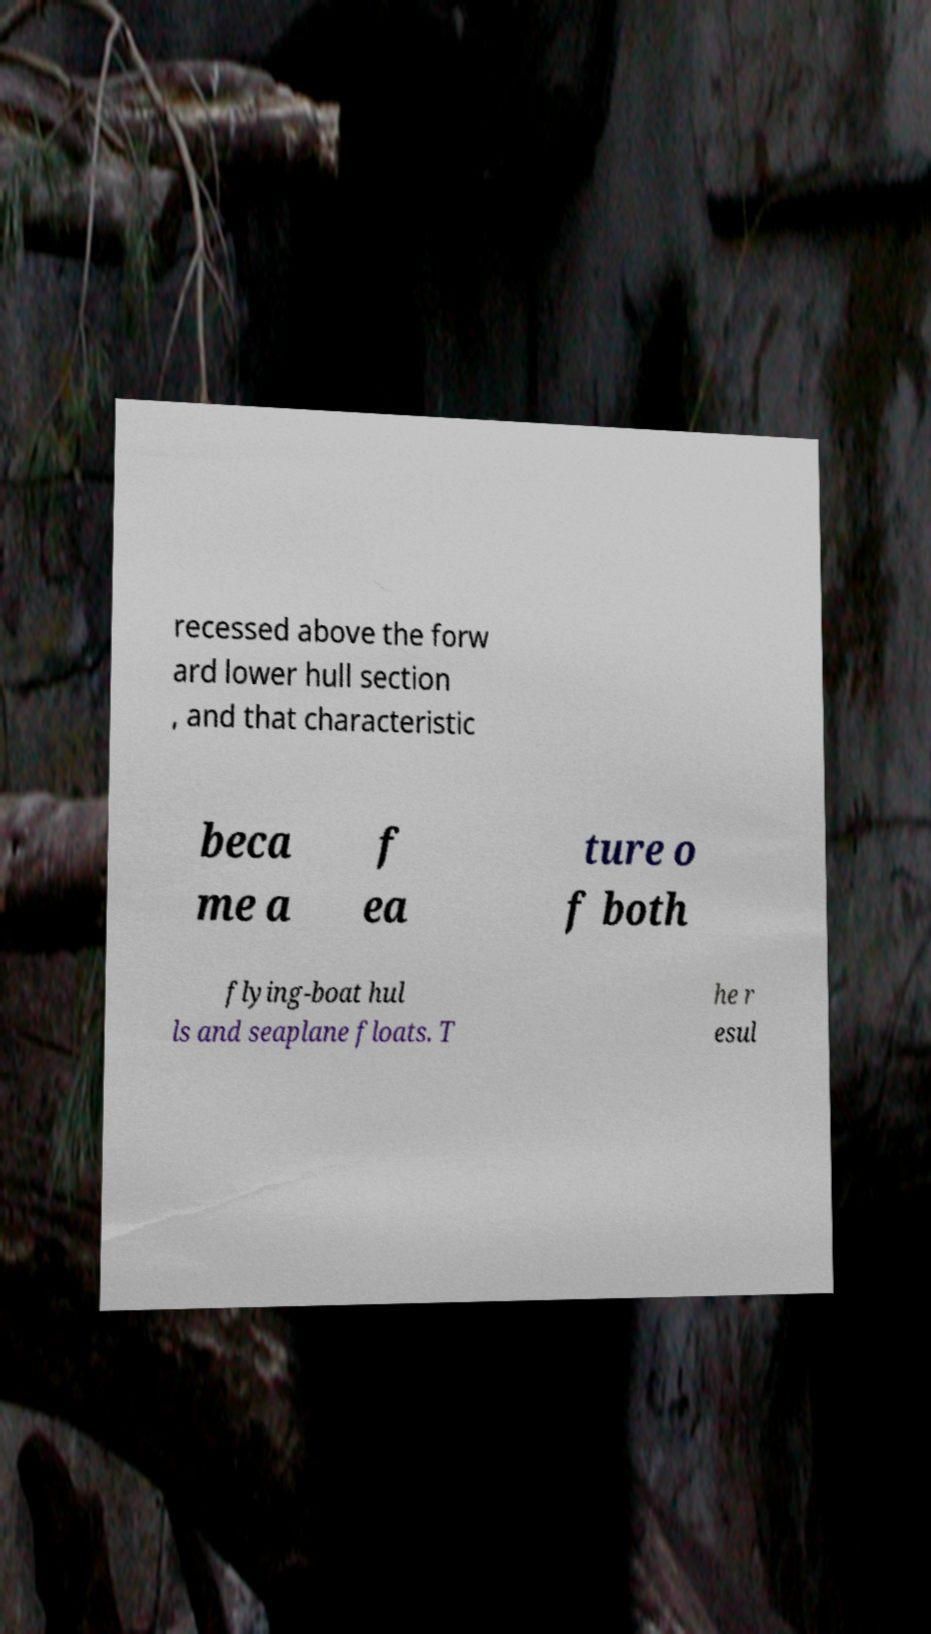What messages or text are displayed in this image? I need them in a readable, typed format. recessed above the forw ard lower hull section , and that characteristic beca me a f ea ture o f both flying-boat hul ls and seaplane floats. T he r esul 